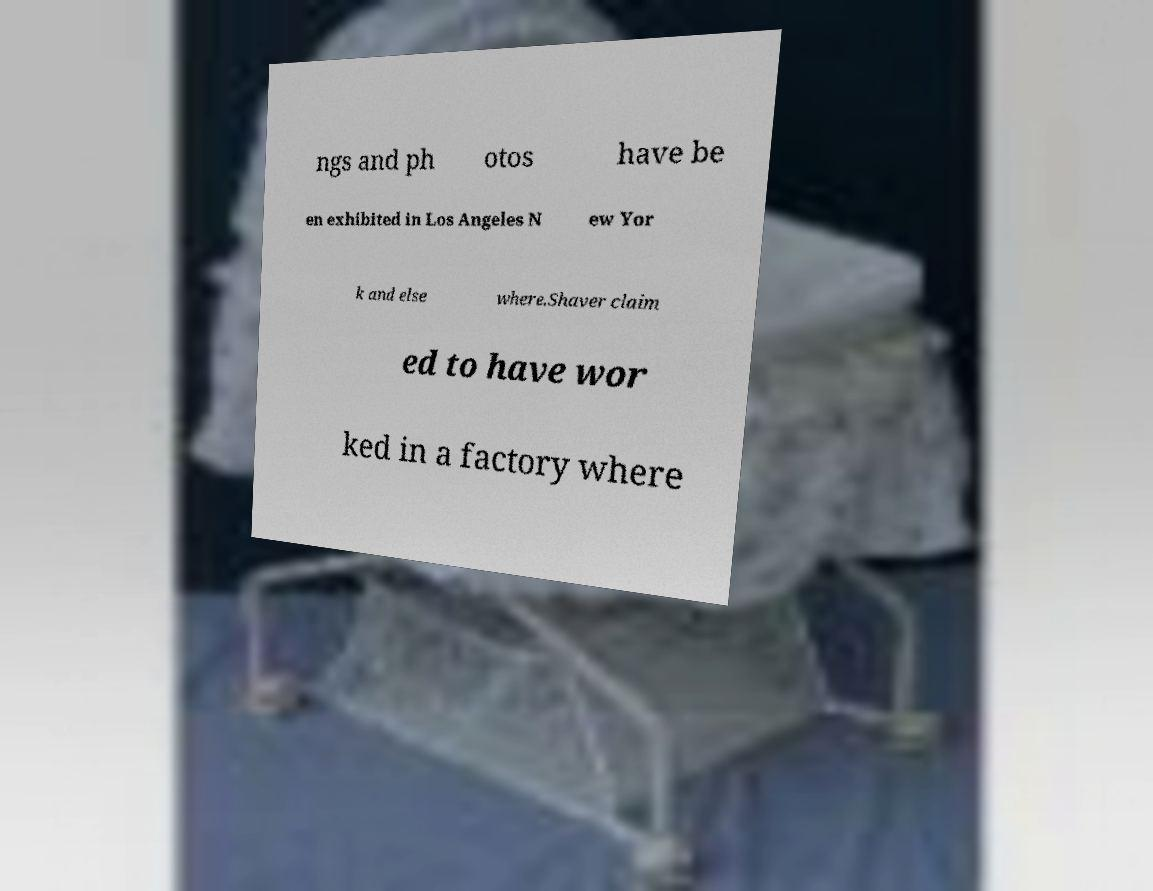Can you accurately transcribe the text from the provided image for me? ngs and ph otos have be en exhibited in Los Angeles N ew Yor k and else where.Shaver claim ed to have wor ked in a factory where 